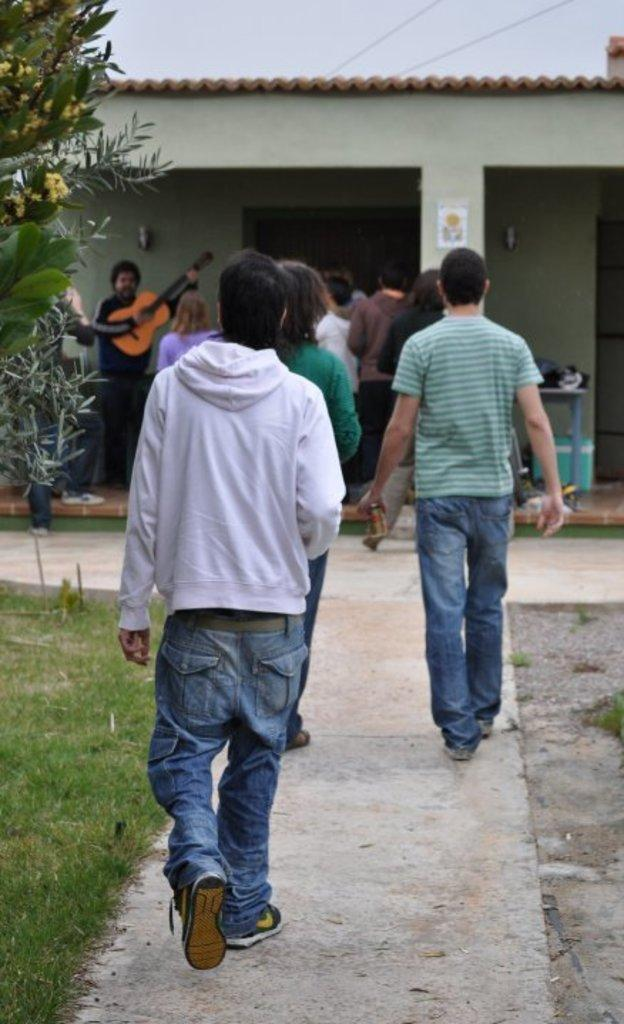What are the people in the image doing? There is a group of people standing in the image, and there are persons walking in the image. What type of terrain is visible in the image? There is grass visible in the image. What natural element can be seen in the image? There is a tree in the image. What is visible in the background of the image? The sky is visible in the image. What type of cushion can be seen supporting the tree in the image? There is no cushion present in the image, and the tree is not supported by any cushion. What is the root of the tree doing in the image? The image does not show the root of the tree, so it is not possible to determine what it might be doing. 